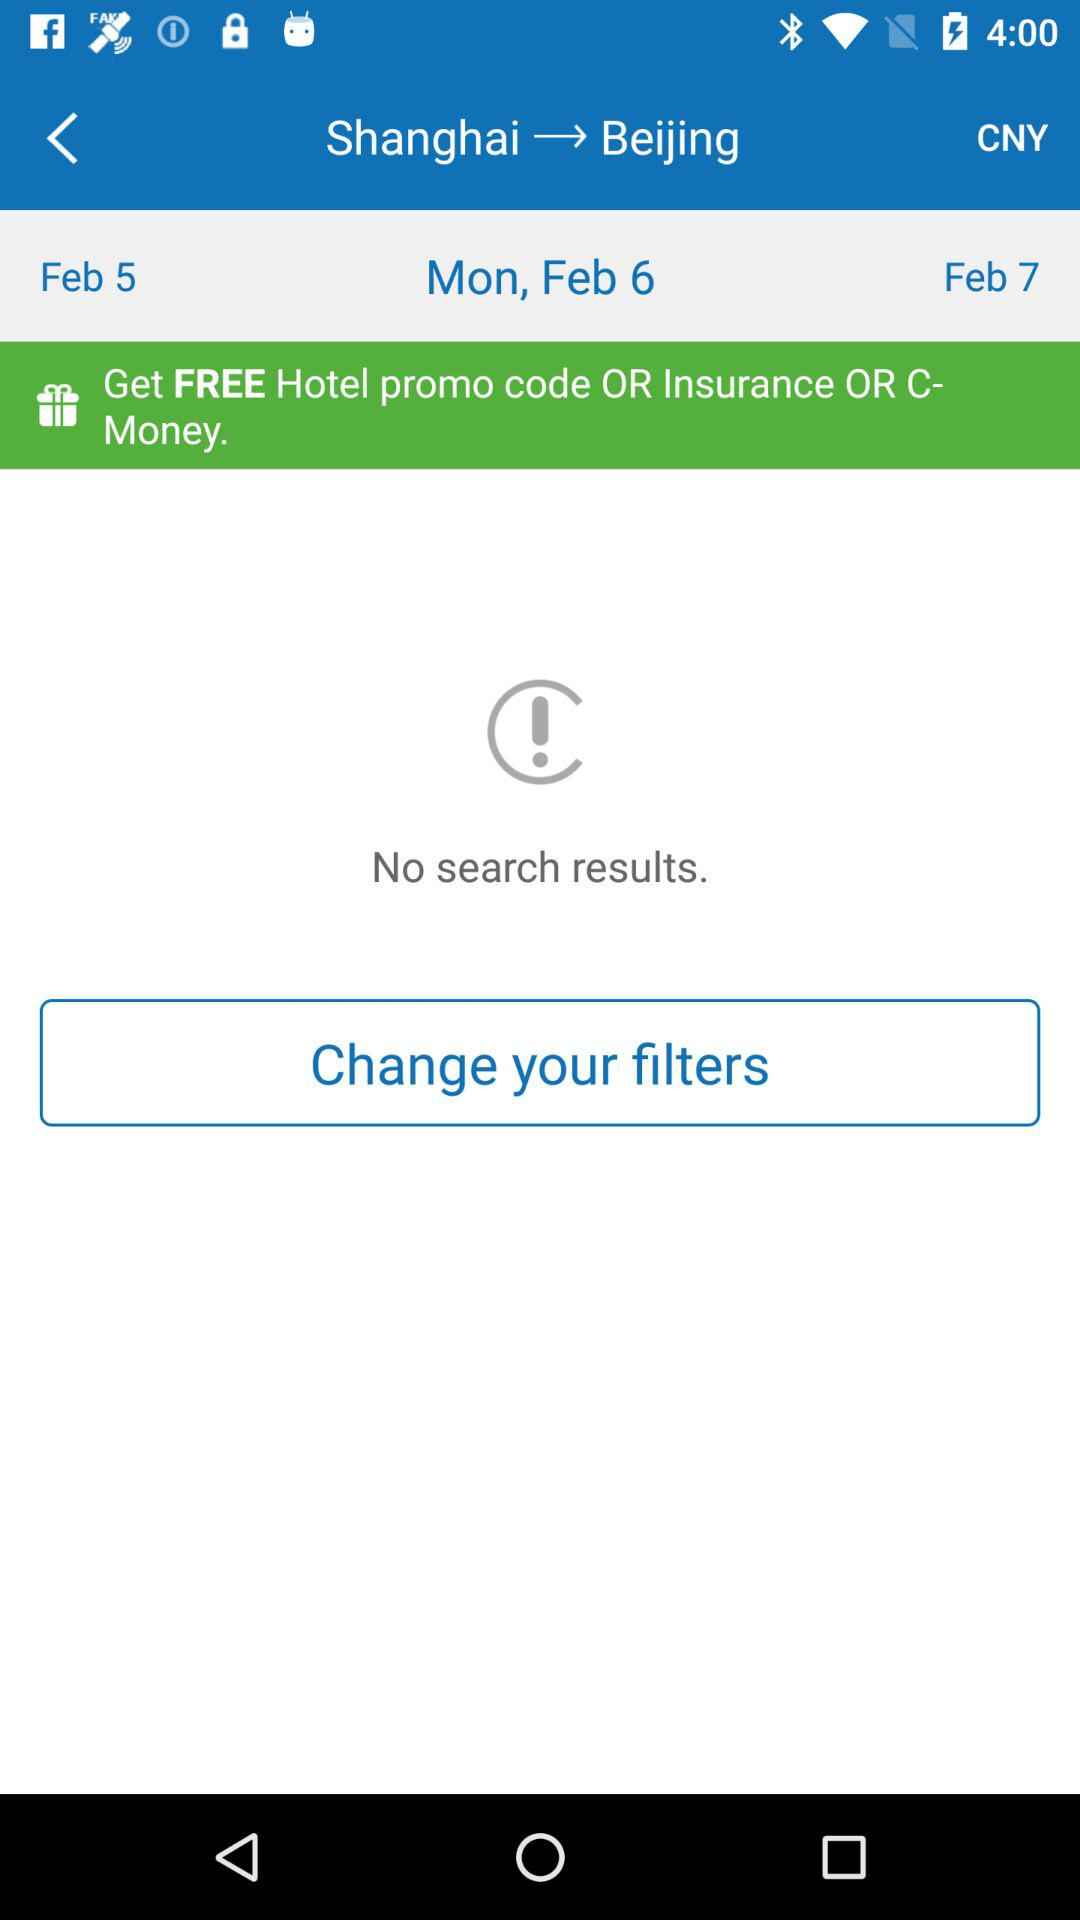What is the selected date? The selected date is Monday, February 6. 